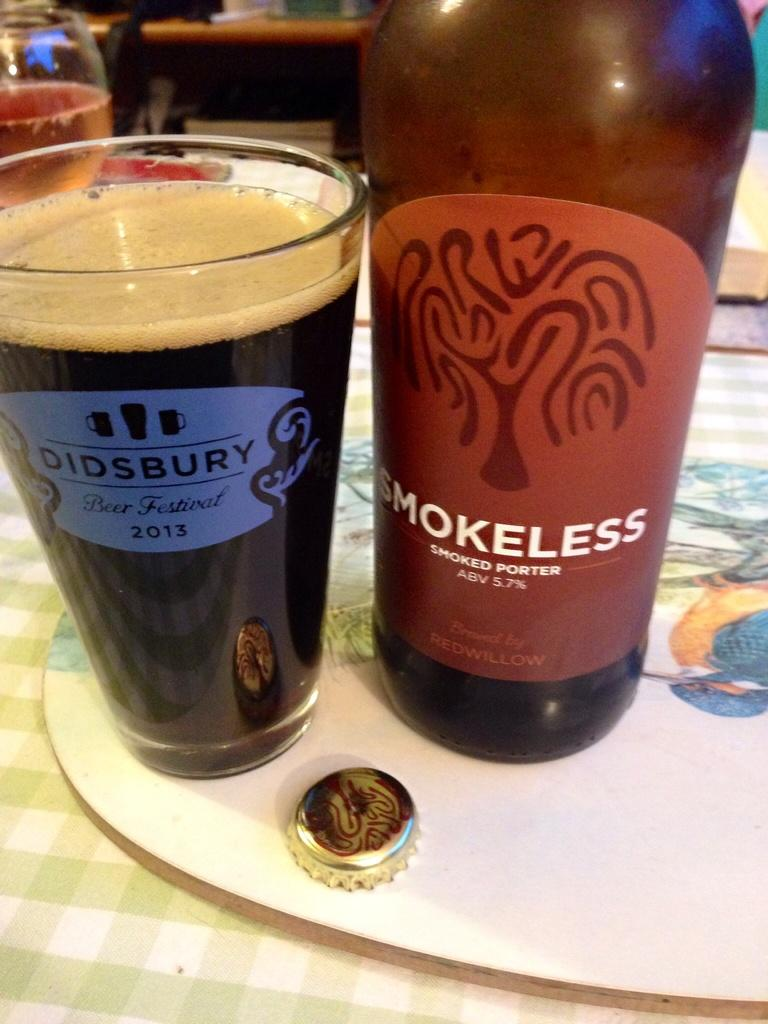What piece of furniture is present in the image? There is a table in the image. What objects are on the table? There is a bottle and a glass of wine on the table. Can you see any nails being hammered into the table in the image? There are no nails or hammering activity present in the image. What type of drum is visible on the table in the image? There is no drum present in the image; only a table, a bottle, and a glass of wine are visible. 